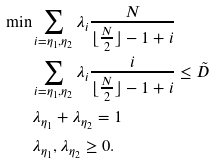Convert formula to latex. <formula><loc_0><loc_0><loc_500><loc_500>\min & \sum _ { i = \eta _ { 1 } , \eta _ { 2 } } \lambda _ { i } \frac { N } { \lfloor \frac { N } { 2 } \rfloor - 1 + i } \\ & \sum _ { i = \eta _ { 1 } , \eta _ { 2 } } \lambda _ { i } \frac { i } { \lfloor \frac { N } { 2 } \rfloor - 1 + i } \leq \tilde { D } \\ & \lambda _ { \eta _ { 1 } } + \lambda _ { \eta _ { 2 } } = 1 \\ & \lambda _ { \eta _ { 1 } } , \lambda _ { \eta _ { 2 } } \geq 0 .</formula> 